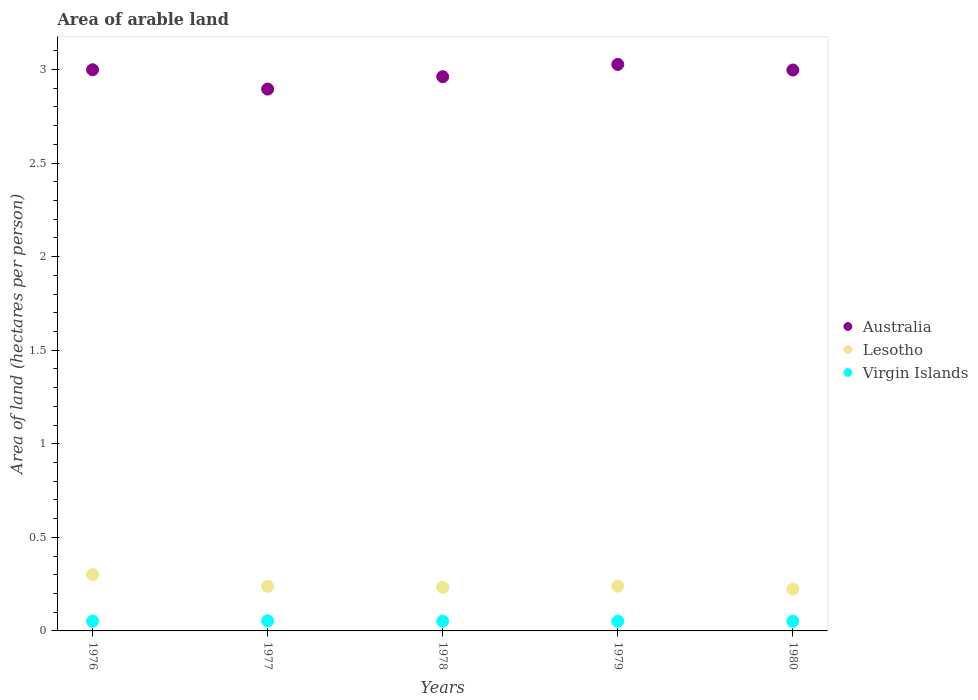Is the number of dotlines equal to the number of legend labels?
Make the answer very short. Yes. What is the total arable land in Lesotho in 1977?
Your answer should be very brief. 0.24. Across all years, what is the maximum total arable land in Lesotho?
Keep it short and to the point. 0.3. Across all years, what is the minimum total arable land in Virgin Islands?
Keep it short and to the point. 0.05. In which year was the total arable land in Virgin Islands maximum?
Make the answer very short. 1977. In which year was the total arable land in Virgin Islands minimum?
Give a very brief answer. 1980. What is the total total arable land in Lesotho in the graph?
Your answer should be compact. 1.24. What is the difference between the total arable land in Lesotho in 1978 and that in 1980?
Ensure brevity in your answer.  0.01. What is the difference between the total arable land in Lesotho in 1980 and the total arable land in Virgin Islands in 1977?
Make the answer very short. 0.17. What is the average total arable land in Virgin Islands per year?
Offer a terse response. 0.05. In the year 1976, what is the difference between the total arable land in Virgin Islands and total arable land in Australia?
Your answer should be compact. -2.95. In how many years, is the total arable land in Australia greater than 2 hectares per person?
Offer a terse response. 5. What is the ratio of the total arable land in Lesotho in 1976 to that in 1980?
Offer a terse response. 1.35. Is the difference between the total arable land in Virgin Islands in 1978 and 1980 greater than the difference between the total arable land in Australia in 1978 and 1980?
Ensure brevity in your answer.  Yes. What is the difference between the highest and the second highest total arable land in Lesotho?
Make the answer very short. 0.06. What is the difference between the highest and the lowest total arable land in Australia?
Give a very brief answer. 0.13. Is the sum of the total arable land in Lesotho in 1979 and 1980 greater than the maximum total arable land in Virgin Islands across all years?
Provide a succinct answer. Yes. Does the total arable land in Australia monotonically increase over the years?
Your response must be concise. No. Is the total arable land in Virgin Islands strictly less than the total arable land in Australia over the years?
Make the answer very short. Yes. How many dotlines are there?
Provide a short and direct response. 3. How many years are there in the graph?
Your response must be concise. 5. Are the values on the major ticks of Y-axis written in scientific E-notation?
Your response must be concise. No. Where does the legend appear in the graph?
Keep it short and to the point. Center right. How are the legend labels stacked?
Ensure brevity in your answer.  Vertical. What is the title of the graph?
Provide a succinct answer. Area of arable land. Does "Mauritania" appear as one of the legend labels in the graph?
Offer a terse response. No. What is the label or title of the X-axis?
Keep it short and to the point. Years. What is the label or title of the Y-axis?
Your answer should be compact. Area of land (hectares per person). What is the Area of land (hectares per person) of Australia in 1976?
Provide a short and direct response. 3. What is the Area of land (hectares per person) in Lesotho in 1976?
Make the answer very short. 0.3. What is the Area of land (hectares per person) of Virgin Islands in 1976?
Your answer should be very brief. 0.05. What is the Area of land (hectares per person) in Australia in 1977?
Your answer should be compact. 2.9. What is the Area of land (hectares per person) of Lesotho in 1977?
Offer a terse response. 0.24. What is the Area of land (hectares per person) of Virgin Islands in 1977?
Make the answer very short. 0.05. What is the Area of land (hectares per person) in Australia in 1978?
Ensure brevity in your answer.  2.96. What is the Area of land (hectares per person) of Lesotho in 1978?
Make the answer very short. 0.23. What is the Area of land (hectares per person) of Virgin Islands in 1978?
Ensure brevity in your answer.  0.05. What is the Area of land (hectares per person) of Australia in 1979?
Give a very brief answer. 3.03. What is the Area of land (hectares per person) in Lesotho in 1979?
Keep it short and to the point. 0.24. What is the Area of land (hectares per person) in Virgin Islands in 1979?
Give a very brief answer. 0.05. What is the Area of land (hectares per person) of Australia in 1980?
Ensure brevity in your answer.  3. What is the Area of land (hectares per person) of Lesotho in 1980?
Your response must be concise. 0.22. What is the Area of land (hectares per person) in Virgin Islands in 1980?
Offer a very short reply. 0.05. Across all years, what is the maximum Area of land (hectares per person) of Australia?
Your answer should be very brief. 3.03. Across all years, what is the maximum Area of land (hectares per person) in Lesotho?
Provide a succinct answer. 0.3. Across all years, what is the maximum Area of land (hectares per person) of Virgin Islands?
Keep it short and to the point. 0.05. Across all years, what is the minimum Area of land (hectares per person) of Australia?
Keep it short and to the point. 2.9. Across all years, what is the minimum Area of land (hectares per person) of Lesotho?
Offer a very short reply. 0.22. Across all years, what is the minimum Area of land (hectares per person) in Virgin Islands?
Your answer should be compact. 0.05. What is the total Area of land (hectares per person) of Australia in the graph?
Make the answer very short. 14.88. What is the total Area of land (hectares per person) in Lesotho in the graph?
Keep it short and to the point. 1.24. What is the total Area of land (hectares per person) in Virgin Islands in the graph?
Ensure brevity in your answer.  0.26. What is the difference between the Area of land (hectares per person) in Australia in 1976 and that in 1977?
Offer a terse response. 0.1. What is the difference between the Area of land (hectares per person) in Lesotho in 1976 and that in 1977?
Provide a short and direct response. 0.06. What is the difference between the Area of land (hectares per person) in Virgin Islands in 1976 and that in 1977?
Give a very brief answer. -0. What is the difference between the Area of land (hectares per person) in Australia in 1976 and that in 1978?
Your response must be concise. 0.04. What is the difference between the Area of land (hectares per person) of Lesotho in 1976 and that in 1978?
Your response must be concise. 0.07. What is the difference between the Area of land (hectares per person) of Australia in 1976 and that in 1979?
Offer a very short reply. -0.03. What is the difference between the Area of land (hectares per person) in Lesotho in 1976 and that in 1979?
Provide a succinct answer. 0.06. What is the difference between the Area of land (hectares per person) in Virgin Islands in 1976 and that in 1979?
Offer a terse response. 0. What is the difference between the Area of land (hectares per person) in Australia in 1976 and that in 1980?
Provide a short and direct response. 0. What is the difference between the Area of land (hectares per person) in Lesotho in 1976 and that in 1980?
Your answer should be compact. 0.08. What is the difference between the Area of land (hectares per person) of Virgin Islands in 1976 and that in 1980?
Your answer should be compact. 0. What is the difference between the Area of land (hectares per person) in Australia in 1977 and that in 1978?
Your answer should be very brief. -0.07. What is the difference between the Area of land (hectares per person) in Lesotho in 1977 and that in 1978?
Your answer should be very brief. 0.01. What is the difference between the Area of land (hectares per person) in Virgin Islands in 1977 and that in 1978?
Your answer should be compact. 0. What is the difference between the Area of land (hectares per person) of Australia in 1977 and that in 1979?
Ensure brevity in your answer.  -0.13. What is the difference between the Area of land (hectares per person) in Lesotho in 1977 and that in 1979?
Provide a succinct answer. -0. What is the difference between the Area of land (hectares per person) in Virgin Islands in 1977 and that in 1979?
Offer a very short reply. 0. What is the difference between the Area of land (hectares per person) of Australia in 1977 and that in 1980?
Your answer should be very brief. -0.1. What is the difference between the Area of land (hectares per person) in Lesotho in 1977 and that in 1980?
Give a very brief answer. 0.01. What is the difference between the Area of land (hectares per person) in Virgin Islands in 1977 and that in 1980?
Give a very brief answer. 0. What is the difference between the Area of land (hectares per person) in Australia in 1978 and that in 1979?
Your response must be concise. -0.07. What is the difference between the Area of land (hectares per person) of Lesotho in 1978 and that in 1979?
Keep it short and to the point. -0.01. What is the difference between the Area of land (hectares per person) of Australia in 1978 and that in 1980?
Provide a succinct answer. -0.04. What is the difference between the Area of land (hectares per person) in Lesotho in 1978 and that in 1980?
Your response must be concise. 0.01. What is the difference between the Area of land (hectares per person) of Virgin Islands in 1978 and that in 1980?
Ensure brevity in your answer.  0. What is the difference between the Area of land (hectares per person) in Australia in 1979 and that in 1980?
Make the answer very short. 0.03. What is the difference between the Area of land (hectares per person) of Lesotho in 1979 and that in 1980?
Your answer should be compact. 0.02. What is the difference between the Area of land (hectares per person) in Australia in 1976 and the Area of land (hectares per person) in Lesotho in 1977?
Ensure brevity in your answer.  2.76. What is the difference between the Area of land (hectares per person) of Australia in 1976 and the Area of land (hectares per person) of Virgin Islands in 1977?
Provide a succinct answer. 2.94. What is the difference between the Area of land (hectares per person) of Lesotho in 1976 and the Area of land (hectares per person) of Virgin Islands in 1977?
Offer a very short reply. 0.25. What is the difference between the Area of land (hectares per person) in Australia in 1976 and the Area of land (hectares per person) in Lesotho in 1978?
Your answer should be very brief. 2.77. What is the difference between the Area of land (hectares per person) of Australia in 1976 and the Area of land (hectares per person) of Virgin Islands in 1978?
Your answer should be compact. 2.95. What is the difference between the Area of land (hectares per person) in Lesotho in 1976 and the Area of land (hectares per person) in Virgin Islands in 1978?
Offer a terse response. 0.25. What is the difference between the Area of land (hectares per person) in Australia in 1976 and the Area of land (hectares per person) in Lesotho in 1979?
Offer a very short reply. 2.76. What is the difference between the Area of land (hectares per person) in Australia in 1976 and the Area of land (hectares per person) in Virgin Islands in 1979?
Provide a succinct answer. 2.95. What is the difference between the Area of land (hectares per person) of Lesotho in 1976 and the Area of land (hectares per person) of Virgin Islands in 1979?
Keep it short and to the point. 0.25. What is the difference between the Area of land (hectares per person) of Australia in 1976 and the Area of land (hectares per person) of Lesotho in 1980?
Your answer should be very brief. 2.77. What is the difference between the Area of land (hectares per person) of Australia in 1976 and the Area of land (hectares per person) of Virgin Islands in 1980?
Give a very brief answer. 2.95. What is the difference between the Area of land (hectares per person) in Lesotho in 1976 and the Area of land (hectares per person) in Virgin Islands in 1980?
Give a very brief answer. 0.25. What is the difference between the Area of land (hectares per person) of Australia in 1977 and the Area of land (hectares per person) of Lesotho in 1978?
Provide a short and direct response. 2.66. What is the difference between the Area of land (hectares per person) of Australia in 1977 and the Area of land (hectares per person) of Virgin Islands in 1978?
Make the answer very short. 2.84. What is the difference between the Area of land (hectares per person) of Lesotho in 1977 and the Area of land (hectares per person) of Virgin Islands in 1978?
Your answer should be very brief. 0.19. What is the difference between the Area of land (hectares per person) in Australia in 1977 and the Area of land (hectares per person) in Lesotho in 1979?
Your response must be concise. 2.66. What is the difference between the Area of land (hectares per person) in Australia in 1977 and the Area of land (hectares per person) in Virgin Islands in 1979?
Your answer should be very brief. 2.84. What is the difference between the Area of land (hectares per person) in Lesotho in 1977 and the Area of land (hectares per person) in Virgin Islands in 1979?
Make the answer very short. 0.19. What is the difference between the Area of land (hectares per person) in Australia in 1977 and the Area of land (hectares per person) in Lesotho in 1980?
Provide a succinct answer. 2.67. What is the difference between the Area of land (hectares per person) in Australia in 1977 and the Area of land (hectares per person) in Virgin Islands in 1980?
Make the answer very short. 2.84. What is the difference between the Area of land (hectares per person) of Lesotho in 1977 and the Area of land (hectares per person) of Virgin Islands in 1980?
Your answer should be compact. 0.19. What is the difference between the Area of land (hectares per person) of Australia in 1978 and the Area of land (hectares per person) of Lesotho in 1979?
Offer a terse response. 2.72. What is the difference between the Area of land (hectares per person) of Australia in 1978 and the Area of land (hectares per person) of Virgin Islands in 1979?
Give a very brief answer. 2.91. What is the difference between the Area of land (hectares per person) of Lesotho in 1978 and the Area of land (hectares per person) of Virgin Islands in 1979?
Provide a short and direct response. 0.18. What is the difference between the Area of land (hectares per person) of Australia in 1978 and the Area of land (hectares per person) of Lesotho in 1980?
Provide a short and direct response. 2.74. What is the difference between the Area of land (hectares per person) in Australia in 1978 and the Area of land (hectares per person) in Virgin Islands in 1980?
Provide a succinct answer. 2.91. What is the difference between the Area of land (hectares per person) in Lesotho in 1978 and the Area of land (hectares per person) in Virgin Islands in 1980?
Offer a terse response. 0.18. What is the difference between the Area of land (hectares per person) in Australia in 1979 and the Area of land (hectares per person) in Lesotho in 1980?
Your answer should be very brief. 2.8. What is the difference between the Area of land (hectares per person) in Australia in 1979 and the Area of land (hectares per person) in Virgin Islands in 1980?
Ensure brevity in your answer.  2.98. What is the difference between the Area of land (hectares per person) of Lesotho in 1979 and the Area of land (hectares per person) of Virgin Islands in 1980?
Provide a succinct answer. 0.19. What is the average Area of land (hectares per person) in Australia per year?
Give a very brief answer. 2.98. What is the average Area of land (hectares per person) in Lesotho per year?
Keep it short and to the point. 0.25. What is the average Area of land (hectares per person) of Virgin Islands per year?
Offer a terse response. 0.05. In the year 1976, what is the difference between the Area of land (hectares per person) in Australia and Area of land (hectares per person) in Lesotho?
Provide a short and direct response. 2.7. In the year 1976, what is the difference between the Area of land (hectares per person) in Australia and Area of land (hectares per person) in Virgin Islands?
Provide a succinct answer. 2.95. In the year 1976, what is the difference between the Area of land (hectares per person) of Lesotho and Area of land (hectares per person) of Virgin Islands?
Your answer should be very brief. 0.25. In the year 1977, what is the difference between the Area of land (hectares per person) of Australia and Area of land (hectares per person) of Lesotho?
Ensure brevity in your answer.  2.66. In the year 1977, what is the difference between the Area of land (hectares per person) of Australia and Area of land (hectares per person) of Virgin Islands?
Give a very brief answer. 2.84. In the year 1977, what is the difference between the Area of land (hectares per person) of Lesotho and Area of land (hectares per person) of Virgin Islands?
Offer a terse response. 0.18. In the year 1978, what is the difference between the Area of land (hectares per person) of Australia and Area of land (hectares per person) of Lesotho?
Offer a very short reply. 2.73. In the year 1978, what is the difference between the Area of land (hectares per person) in Australia and Area of land (hectares per person) in Virgin Islands?
Give a very brief answer. 2.91. In the year 1978, what is the difference between the Area of land (hectares per person) of Lesotho and Area of land (hectares per person) of Virgin Islands?
Keep it short and to the point. 0.18. In the year 1979, what is the difference between the Area of land (hectares per person) of Australia and Area of land (hectares per person) of Lesotho?
Provide a succinct answer. 2.79. In the year 1979, what is the difference between the Area of land (hectares per person) in Australia and Area of land (hectares per person) in Virgin Islands?
Provide a succinct answer. 2.97. In the year 1979, what is the difference between the Area of land (hectares per person) of Lesotho and Area of land (hectares per person) of Virgin Islands?
Make the answer very short. 0.19. In the year 1980, what is the difference between the Area of land (hectares per person) of Australia and Area of land (hectares per person) of Lesotho?
Your answer should be compact. 2.77. In the year 1980, what is the difference between the Area of land (hectares per person) of Australia and Area of land (hectares per person) of Virgin Islands?
Your answer should be compact. 2.95. In the year 1980, what is the difference between the Area of land (hectares per person) of Lesotho and Area of land (hectares per person) of Virgin Islands?
Your answer should be compact. 0.17. What is the ratio of the Area of land (hectares per person) of Australia in 1976 to that in 1977?
Your answer should be compact. 1.04. What is the ratio of the Area of land (hectares per person) of Lesotho in 1976 to that in 1977?
Give a very brief answer. 1.26. What is the ratio of the Area of land (hectares per person) in Virgin Islands in 1976 to that in 1977?
Your response must be concise. 0.97. What is the ratio of the Area of land (hectares per person) of Australia in 1976 to that in 1978?
Your answer should be very brief. 1.01. What is the ratio of the Area of land (hectares per person) of Lesotho in 1976 to that in 1978?
Keep it short and to the point. 1.29. What is the ratio of the Area of land (hectares per person) of Virgin Islands in 1976 to that in 1978?
Give a very brief answer. 1. What is the ratio of the Area of land (hectares per person) in Australia in 1976 to that in 1979?
Offer a terse response. 0.99. What is the ratio of the Area of land (hectares per person) of Lesotho in 1976 to that in 1979?
Ensure brevity in your answer.  1.26. What is the ratio of the Area of land (hectares per person) of Virgin Islands in 1976 to that in 1979?
Your answer should be very brief. 1. What is the ratio of the Area of land (hectares per person) of Australia in 1976 to that in 1980?
Offer a terse response. 1. What is the ratio of the Area of land (hectares per person) in Lesotho in 1976 to that in 1980?
Offer a very short reply. 1.35. What is the ratio of the Area of land (hectares per person) in Virgin Islands in 1976 to that in 1980?
Your answer should be compact. 1.01. What is the ratio of the Area of land (hectares per person) in Australia in 1977 to that in 1978?
Offer a very short reply. 0.98. What is the ratio of the Area of land (hectares per person) of Lesotho in 1977 to that in 1978?
Provide a succinct answer. 1.02. What is the ratio of the Area of land (hectares per person) in Virgin Islands in 1977 to that in 1978?
Offer a terse response. 1.03. What is the ratio of the Area of land (hectares per person) in Australia in 1977 to that in 1979?
Your response must be concise. 0.96. What is the ratio of the Area of land (hectares per person) of Virgin Islands in 1977 to that in 1979?
Make the answer very short. 1.03. What is the ratio of the Area of land (hectares per person) of Australia in 1977 to that in 1980?
Your answer should be compact. 0.97. What is the ratio of the Area of land (hectares per person) in Lesotho in 1977 to that in 1980?
Your response must be concise. 1.07. What is the ratio of the Area of land (hectares per person) of Virgin Islands in 1977 to that in 1980?
Offer a terse response. 1.04. What is the ratio of the Area of land (hectares per person) in Australia in 1978 to that in 1979?
Your response must be concise. 0.98. What is the ratio of the Area of land (hectares per person) of Lesotho in 1978 to that in 1979?
Keep it short and to the point. 0.97. What is the ratio of the Area of land (hectares per person) in Lesotho in 1978 to that in 1980?
Your answer should be very brief. 1.04. What is the ratio of the Area of land (hectares per person) of Virgin Islands in 1978 to that in 1980?
Give a very brief answer. 1.01. What is the ratio of the Area of land (hectares per person) in Australia in 1979 to that in 1980?
Your response must be concise. 1.01. What is the ratio of the Area of land (hectares per person) in Lesotho in 1979 to that in 1980?
Make the answer very short. 1.07. What is the ratio of the Area of land (hectares per person) of Virgin Islands in 1979 to that in 1980?
Keep it short and to the point. 1.01. What is the difference between the highest and the second highest Area of land (hectares per person) of Australia?
Ensure brevity in your answer.  0.03. What is the difference between the highest and the second highest Area of land (hectares per person) of Lesotho?
Your response must be concise. 0.06. What is the difference between the highest and the second highest Area of land (hectares per person) of Virgin Islands?
Give a very brief answer. 0. What is the difference between the highest and the lowest Area of land (hectares per person) of Australia?
Provide a short and direct response. 0.13. What is the difference between the highest and the lowest Area of land (hectares per person) in Lesotho?
Your answer should be compact. 0.08. What is the difference between the highest and the lowest Area of land (hectares per person) of Virgin Islands?
Offer a terse response. 0. 